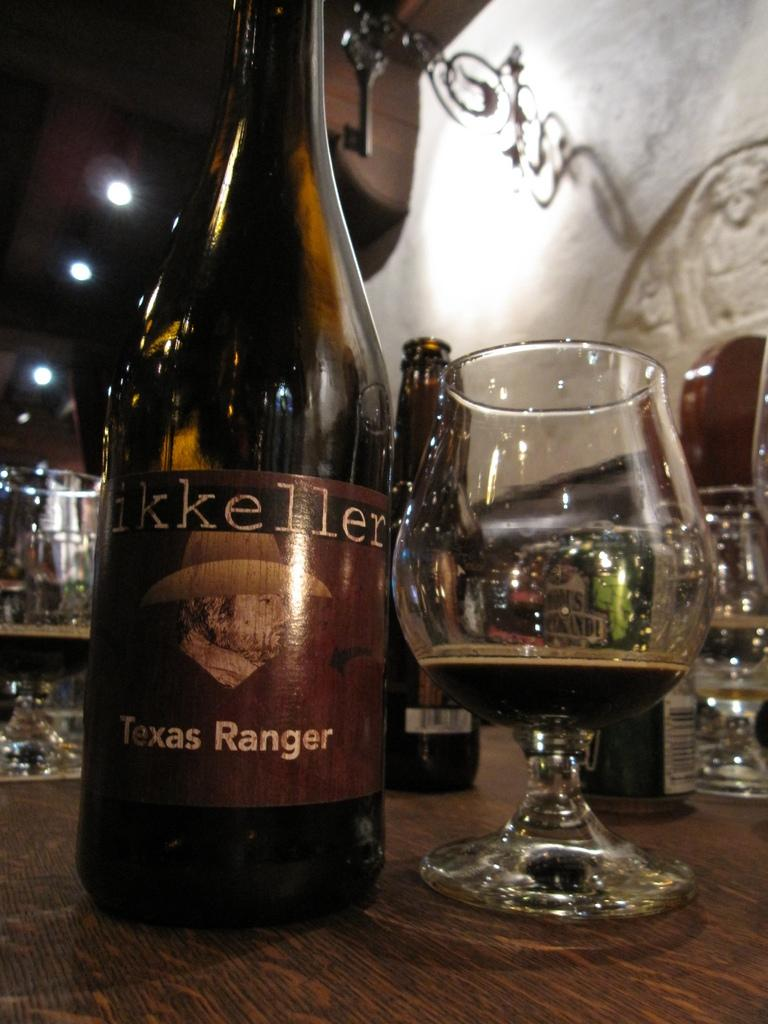What objects are visible in the image that contain liquid? There are bottles and glasses with beer in the image. Where are the bottles and glasses placed? The bottles and glasses are placed on a table. What can be seen on the wall in the image? There is a decal on a wall in the image. What type of lighting is present in the image? There are ceiling lights in the image. How much money is being exchanged at the event in the image? There is no event or exchange of money depicted in the image; it features bottles, glasses with beer, a table, a decal on a wall, and ceiling lights. 